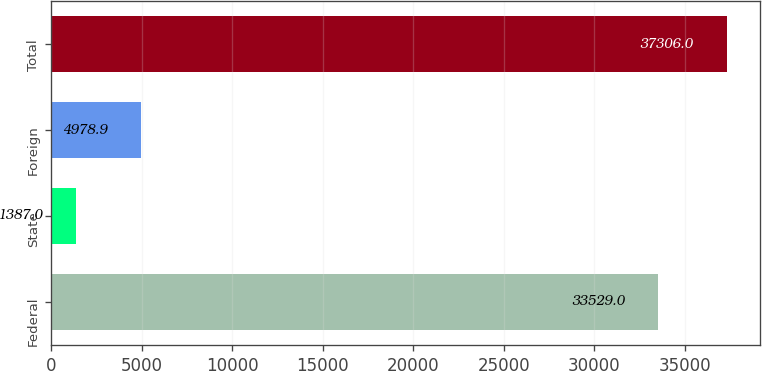<chart> <loc_0><loc_0><loc_500><loc_500><bar_chart><fcel>Federal<fcel>State<fcel>Foreign<fcel>Total<nl><fcel>33529<fcel>1387<fcel>4978.9<fcel>37306<nl></chart> 